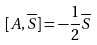<formula> <loc_0><loc_0><loc_500><loc_500>[ A , \overline { S } ] = - \frac { 1 } { 2 } \overline { S }</formula> 